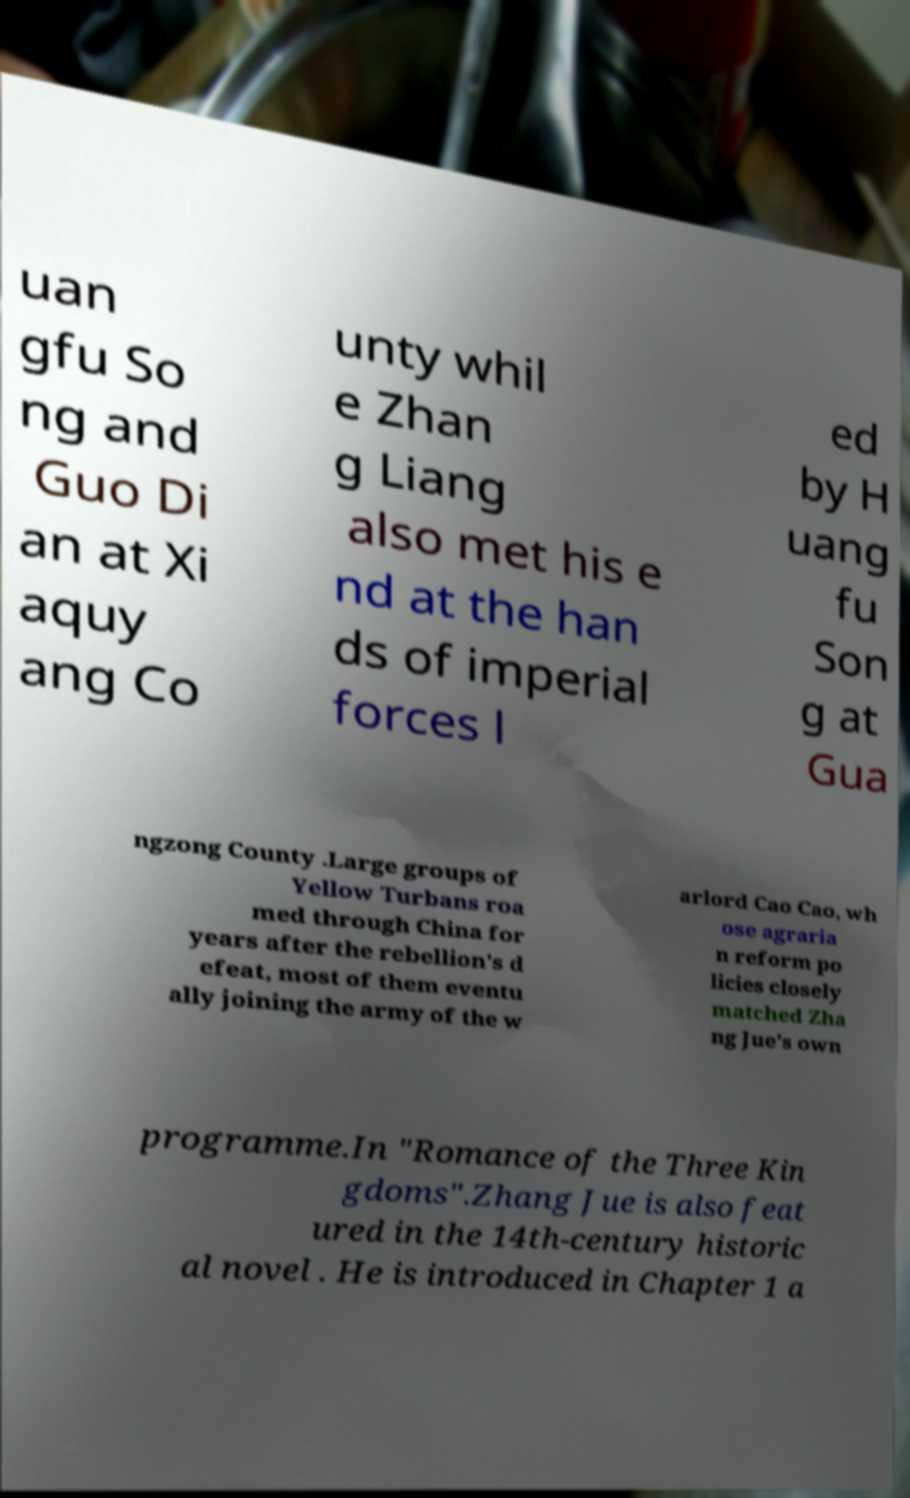For documentation purposes, I need the text within this image transcribed. Could you provide that? uan gfu So ng and Guo Di an at Xi aquy ang Co unty whil e Zhan g Liang also met his e nd at the han ds of imperial forces l ed by H uang fu Son g at Gua ngzong County .Large groups of Yellow Turbans roa med through China for years after the rebellion's d efeat, most of them eventu ally joining the army of the w arlord Cao Cao, wh ose agraria n reform po licies closely matched Zha ng Jue's own programme.In "Romance of the Three Kin gdoms".Zhang Jue is also feat ured in the 14th-century historic al novel . He is introduced in Chapter 1 a 